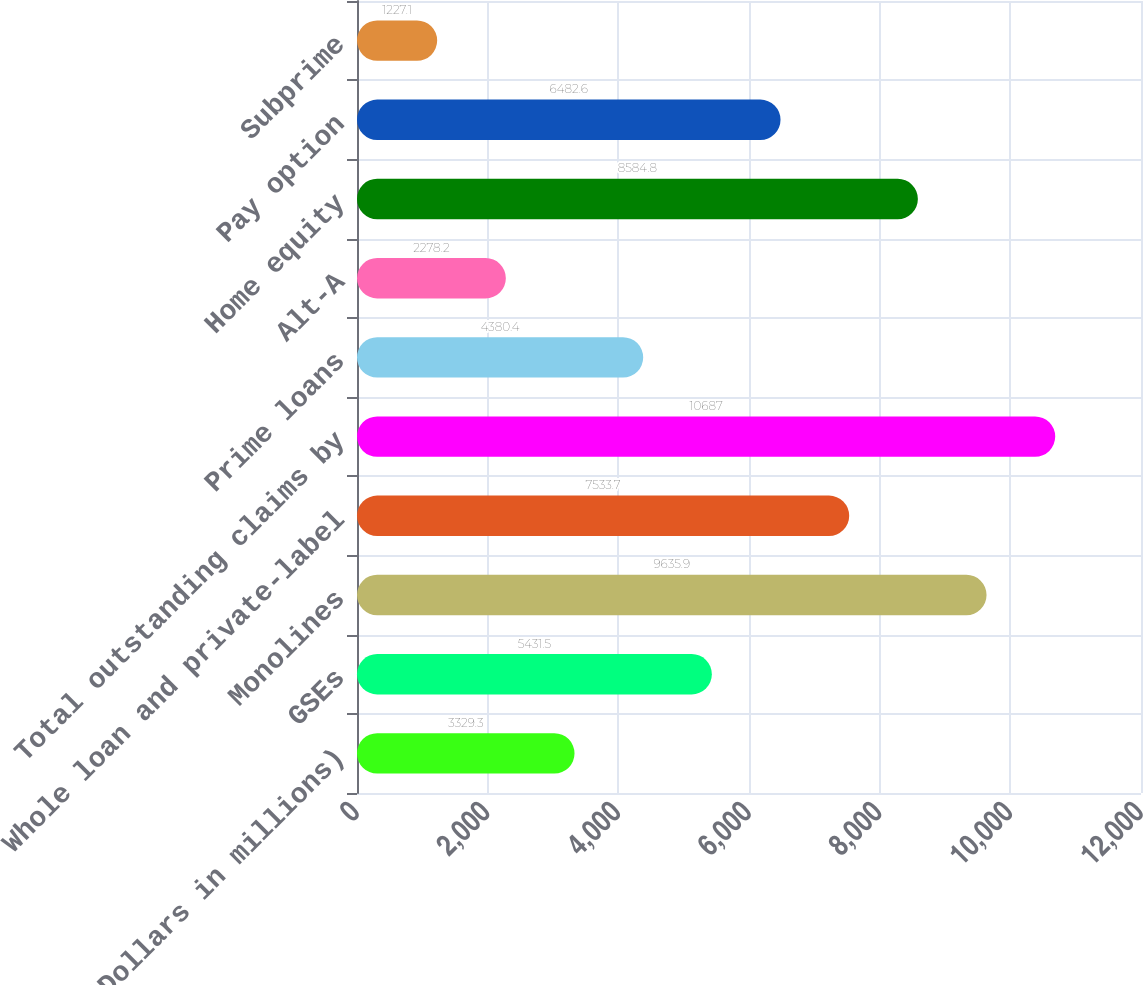<chart> <loc_0><loc_0><loc_500><loc_500><bar_chart><fcel>(Dollars in millions)<fcel>GSEs<fcel>Monolines<fcel>Whole loan and private-label<fcel>Total outstanding claims by<fcel>Prime loans<fcel>Alt-A<fcel>Home equity<fcel>Pay option<fcel>Subprime<nl><fcel>3329.3<fcel>5431.5<fcel>9635.9<fcel>7533.7<fcel>10687<fcel>4380.4<fcel>2278.2<fcel>8584.8<fcel>6482.6<fcel>1227.1<nl></chart> 